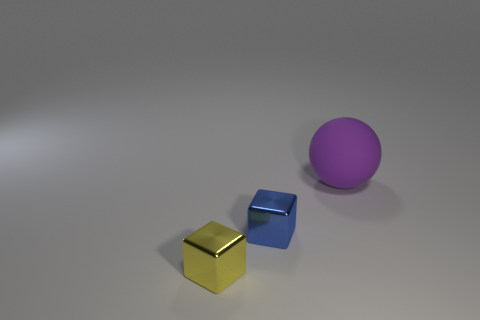Is there any other thing that has the same size as the rubber object?
Provide a succinct answer. No. Do the purple object that is behind the tiny blue object and the yellow object have the same shape?
Give a very brief answer. No. How many other purple matte things have the same shape as the matte object?
Make the answer very short. 0. Are there any blocks that have the same material as the tiny blue object?
Ensure brevity in your answer.  Yes. What material is the tiny thing that is behind the block that is in front of the blue cube?
Make the answer very short. Metal. There is a metal thing behind the yellow metallic object; how big is it?
Ensure brevity in your answer.  Small. Does the blue cube have the same material as the cube that is to the left of the blue block?
Your answer should be very brief. Yes. How many large objects are either purple rubber objects or yellow cubes?
Make the answer very short. 1. Is the number of tiny yellow metallic things less than the number of tiny gray cylinders?
Offer a terse response. No. There is a shiny cube that is to the left of the small blue thing; is it the same size as the purple matte sphere behind the blue thing?
Offer a very short reply. No. 